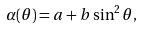Convert formula to latex. <formula><loc_0><loc_0><loc_500><loc_500>\alpha ( \theta ) = a + b \sin ^ { 2 } \theta ,</formula> 